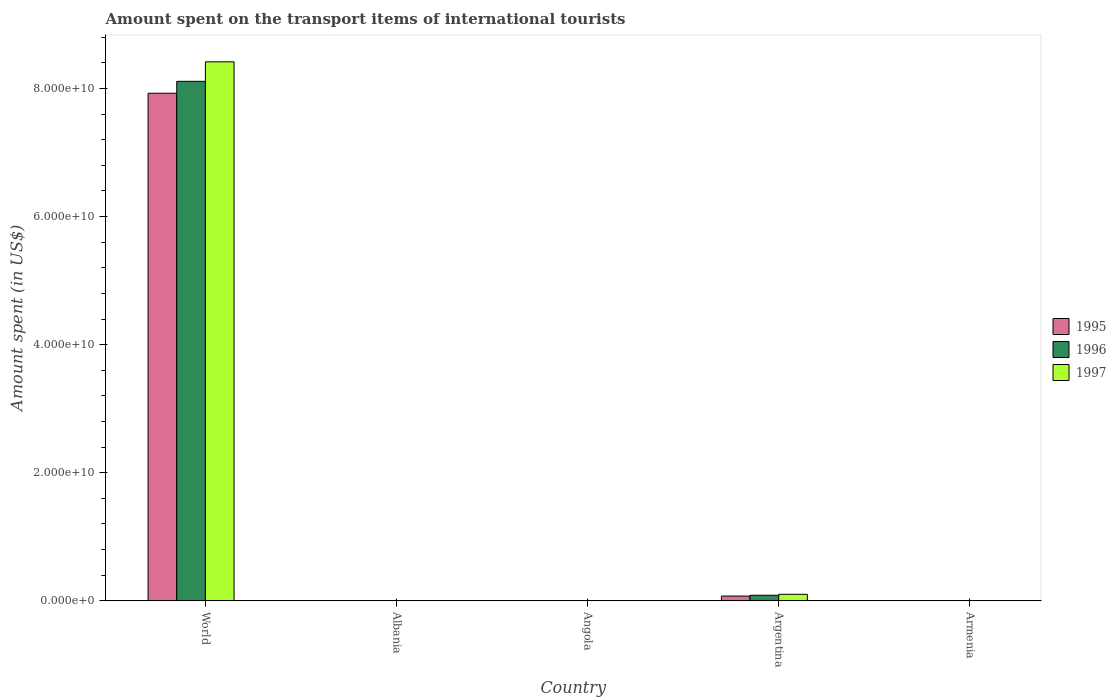How many different coloured bars are there?
Provide a short and direct response. 3. Are the number of bars on each tick of the X-axis equal?
Provide a short and direct response. Yes. How many bars are there on the 2nd tick from the right?
Your answer should be very brief. 3. What is the label of the 5th group of bars from the left?
Your response must be concise. Armenia. What is the amount spent on the transport items of international tourists in 1995 in Angola?
Your answer should be very brief. 3.78e+07. Across all countries, what is the maximum amount spent on the transport items of international tourists in 1997?
Offer a terse response. 8.42e+1. Across all countries, what is the minimum amount spent on the transport items of international tourists in 1997?
Provide a short and direct response. 4.00e+06. In which country was the amount spent on the transport items of international tourists in 1995 minimum?
Keep it short and to the point. Armenia. What is the total amount spent on the transport items of international tourists in 1995 in the graph?
Your response must be concise. 8.00e+1. What is the difference between the amount spent on the transport items of international tourists in 1995 in Armenia and that in World?
Your response must be concise. -7.92e+1. What is the difference between the amount spent on the transport items of international tourists in 1997 in Armenia and the amount spent on the transport items of international tourists in 1995 in Angola?
Provide a succinct answer. -3.38e+07. What is the average amount spent on the transport items of international tourists in 1996 per country?
Offer a terse response. 1.64e+1. What is the difference between the amount spent on the transport items of international tourists of/in 1996 and amount spent on the transport items of international tourists of/in 1997 in Argentina?
Offer a very short reply. -1.46e+08. In how many countries, is the amount spent on the transport items of international tourists in 1995 greater than 16000000000 US$?
Keep it short and to the point. 1. What is the ratio of the amount spent on the transport items of international tourists in 1996 in Angola to that in Armenia?
Make the answer very short. 9.34. Is the amount spent on the transport items of international tourists in 1996 in Albania less than that in Angola?
Provide a succinct answer. Yes. What is the difference between the highest and the second highest amount spent on the transport items of international tourists in 1995?
Ensure brevity in your answer.  6.97e+08. What is the difference between the highest and the lowest amount spent on the transport items of international tourists in 1997?
Your response must be concise. 8.42e+1. In how many countries, is the amount spent on the transport items of international tourists in 1997 greater than the average amount spent on the transport items of international tourists in 1997 taken over all countries?
Your answer should be very brief. 1. What does the 2nd bar from the left in World represents?
Your answer should be very brief. 1996. How many bars are there?
Keep it short and to the point. 15. Are all the bars in the graph horizontal?
Ensure brevity in your answer.  No. How many countries are there in the graph?
Provide a short and direct response. 5. What is the difference between two consecutive major ticks on the Y-axis?
Ensure brevity in your answer.  2.00e+1. Are the values on the major ticks of Y-axis written in scientific E-notation?
Keep it short and to the point. Yes. Does the graph contain any zero values?
Offer a very short reply. No. Where does the legend appear in the graph?
Offer a very short reply. Center right. How are the legend labels stacked?
Offer a very short reply. Vertical. What is the title of the graph?
Keep it short and to the point. Amount spent on the transport items of international tourists. Does "2008" appear as one of the legend labels in the graph?
Make the answer very short. No. What is the label or title of the X-axis?
Make the answer very short. Country. What is the label or title of the Y-axis?
Your answer should be compact. Amount spent (in US$). What is the Amount spent (in US$) of 1995 in World?
Your answer should be compact. 7.93e+1. What is the Amount spent (in US$) in 1996 in World?
Give a very brief answer. 8.11e+1. What is the Amount spent (in US$) of 1997 in World?
Make the answer very short. 8.42e+1. What is the Amount spent (in US$) of 1995 in Albania?
Provide a short and direct response. 1.20e+07. What is the Amount spent (in US$) in 1996 in Albania?
Provide a succinct answer. 1.30e+07. What is the Amount spent (in US$) in 1995 in Angola?
Make the answer very short. 3.78e+07. What is the Amount spent (in US$) in 1996 in Angola?
Give a very brief answer. 3.74e+07. What is the Amount spent (in US$) of 1997 in Angola?
Make the answer very short. 2.72e+07. What is the Amount spent (in US$) in 1995 in Argentina?
Give a very brief answer. 7.35e+08. What is the Amount spent (in US$) in 1996 in Argentina?
Your response must be concise. 8.65e+08. What is the Amount spent (in US$) in 1997 in Argentina?
Make the answer very short. 1.01e+09. What is the Amount spent (in US$) in 1995 in Armenia?
Your answer should be compact. 9.00e+06. What is the Amount spent (in US$) of 1996 in Armenia?
Make the answer very short. 4.00e+06. What is the Amount spent (in US$) in 1997 in Armenia?
Keep it short and to the point. 4.00e+06. Across all countries, what is the maximum Amount spent (in US$) of 1995?
Offer a terse response. 7.93e+1. Across all countries, what is the maximum Amount spent (in US$) in 1996?
Provide a succinct answer. 8.11e+1. Across all countries, what is the maximum Amount spent (in US$) in 1997?
Provide a succinct answer. 8.42e+1. Across all countries, what is the minimum Amount spent (in US$) in 1995?
Your response must be concise. 9.00e+06. Across all countries, what is the minimum Amount spent (in US$) of 1996?
Your answer should be very brief. 4.00e+06. What is the total Amount spent (in US$) of 1995 in the graph?
Make the answer very short. 8.00e+1. What is the total Amount spent (in US$) of 1996 in the graph?
Your response must be concise. 8.20e+1. What is the total Amount spent (in US$) of 1997 in the graph?
Give a very brief answer. 8.52e+1. What is the difference between the Amount spent (in US$) of 1995 in World and that in Albania?
Offer a very short reply. 7.92e+1. What is the difference between the Amount spent (in US$) in 1996 in World and that in Albania?
Offer a very short reply. 8.11e+1. What is the difference between the Amount spent (in US$) of 1997 in World and that in Albania?
Offer a terse response. 8.42e+1. What is the difference between the Amount spent (in US$) of 1995 in World and that in Angola?
Your answer should be very brief. 7.92e+1. What is the difference between the Amount spent (in US$) of 1996 in World and that in Angola?
Make the answer very short. 8.11e+1. What is the difference between the Amount spent (in US$) of 1997 in World and that in Angola?
Your answer should be compact. 8.41e+1. What is the difference between the Amount spent (in US$) in 1995 in World and that in Argentina?
Keep it short and to the point. 7.85e+1. What is the difference between the Amount spent (in US$) in 1996 in World and that in Argentina?
Offer a terse response. 8.03e+1. What is the difference between the Amount spent (in US$) of 1997 in World and that in Argentina?
Provide a short and direct response. 8.32e+1. What is the difference between the Amount spent (in US$) in 1995 in World and that in Armenia?
Give a very brief answer. 7.92e+1. What is the difference between the Amount spent (in US$) of 1996 in World and that in Armenia?
Give a very brief answer. 8.11e+1. What is the difference between the Amount spent (in US$) of 1997 in World and that in Armenia?
Provide a succinct answer. 8.42e+1. What is the difference between the Amount spent (in US$) of 1995 in Albania and that in Angola?
Your answer should be very brief. -2.58e+07. What is the difference between the Amount spent (in US$) in 1996 in Albania and that in Angola?
Make the answer very short. -2.44e+07. What is the difference between the Amount spent (in US$) in 1997 in Albania and that in Angola?
Provide a short and direct response. -1.92e+07. What is the difference between the Amount spent (in US$) in 1995 in Albania and that in Argentina?
Provide a short and direct response. -7.23e+08. What is the difference between the Amount spent (in US$) in 1996 in Albania and that in Argentina?
Make the answer very short. -8.52e+08. What is the difference between the Amount spent (in US$) in 1997 in Albania and that in Argentina?
Provide a succinct answer. -1.00e+09. What is the difference between the Amount spent (in US$) in 1995 in Albania and that in Armenia?
Provide a succinct answer. 3.00e+06. What is the difference between the Amount spent (in US$) in 1996 in Albania and that in Armenia?
Ensure brevity in your answer.  9.00e+06. What is the difference between the Amount spent (in US$) in 1997 in Albania and that in Armenia?
Provide a short and direct response. 4.00e+06. What is the difference between the Amount spent (in US$) in 1995 in Angola and that in Argentina?
Your answer should be compact. -6.97e+08. What is the difference between the Amount spent (in US$) in 1996 in Angola and that in Argentina?
Offer a very short reply. -8.28e+08. What is the difference between the Amount spent (in US$) in 1997 in Angola and that in Argentina?
Ensure brevity in your answer.  -9.84e+08. What is the difference between the Amount spent (in US$) in 1995 in Angola and that in Armenia?
Provide a succinct answer. 2.88e+07. What is the difference between the Amount spent (in US$) in 1996 in Angola and that in Armenia?
Offer a very short reply. 3.34e+07. What is the difference between the Amount spent (in US$) in 1997 in Angola and that in Armenia?
Make the answer very short. 2.32e+07. What is the difference between the Amount spent (in US$) of 1995 in Argentina and that in Armenia?
Provide a succinct answer. 7.26e+08. What is the difference between the Amount spent (in US$) in 1996 in Argentina and that in Armenia?
Give a very brief answer. 8.61e+08. What is the difference between the Amount spent (in US$) in 1997 in Argentina and that in Armenia?
Make the answer very short. 1.01e+09. What is the difference between the Amount spent (in US$) of 1995 in World and the Amount spent (in US$) of 1996 in Albania?
Provide a short and direct response. 7.92e+1. What is the difference between the Amount spent (in US$) of 1995 in World and the Amount spent (in US$) of 1997 in Albania?
Keep it short and to the point. 7.92e+1. What is the difference between the Amount spent (in US$) of 1996 in World and the Amount spent (in US$) of 1997 in Albania?
Make the answer very short. 8.11e+1. What is the difference between the Amount spent (in US$) in 1995 in World and the Amount spent (in US$) in 1996 in Angola?
Offer a terse response. 7.92e+1. What is the difference between the Amount spent (in US$) in 1995 in World and the Amount spent (in US$) in 1997 in Angola?
Your answer should be compact. 7.92e+1. What is the difference between the Amount spent (in US$) of 1996 in World and the Amount spent (in US$) of 1997 in Angola?
Provide a succinct answer. 8.11e+1. What is the difference between the Amount spent (in US$) in 1995 in World and the Amount spent (in US$) in 1996 in Argentina?
Make the answer very short. 7.84e+1. What is the difference between the Amount spent (in US$) in 1995 in World and the Amount spent (in US$) in 1997 in Argentina?
Offer a terse response. 7.82e+1. What is the difference between the Amount spent (in US$) of 1996 in World and the Amount spent (in US$) of 1997 in Argentina?
Give a very brief answer. 8.01e+1. What is the difference between the Amount spent (in US$) in 1995 in World and the Amount spent (in US$) in 1996 in Armenia?
Provide a short and direct response. 7.92e+1. What is the difference between the Amount spent (in US$) of 1995 in World and the Amount spent (in US$) of 1997 in Armenia?
Make the answer very short. 7.92e+1. What is the difference between the Amount spent (in US$) in 1996 in World and the Amount spent (in US$) in 1997 in Armenia?
Make the answer very short. 8.11e+1. What is the difference between the Amount spent (in US$) in 1995 in Albania and the Amount spent (in US$) in 1996 in Angola?
Give a very brief answer. -2.54e+07. What is the difference between the Amount spent (in US$) of 1995 in Albania and the Amount spent (in US$) of 1997 in Angola?
Your answer should be compact. -1.52e+07. What is the difference between the Amount spent (in US$) in 1996 in Albania and the Amount spent (in US$) in 1997 in Angola?
Ensure brevity in your answer.  -1.42e+07. What is the difference between the Amount spent (in US$) in 1995 in Albania and the Amount spent (in US$) in 1996 in Argentina?
Offer a very short reply. -8.53e+08. What is the difference between the Amount spent (in US$) of 1995 in Albania and the Amount spent (in US$) of 1997 in Argentina?
Give a very brief answer. -9.99e+08. What is the difference between the Amount spent (in US$) of 1996 in Albania and the Amount spent (in US$) of 1997 in Argentina?
Your answer should be very brief. -9.98e+08. What is the difference between the Amount spent (in US$) in 1996 in Albania and the Amount spent (in US$) in 1997 in Armenia?
Provide a succinct answer. 9.00e+06. What is the difference between the Amount spent (in US$) in 1995 in Angola and the Amount spent (in US$) in 1996 in Argentina?
Your answer should be compact. -8.27e+08. What is the difference between the Amount spent (in US$) of 1995 in Angola and the Amount spent (in US$) of 1997 in Argentina?
Offer a very short reply. -9.73e+08. What is the difference between the Amount spent (in US$) of 1996 in Angola and the Amount spent (in US$) of 1997 in Argentina?
Keep it short and to the point. -9.74e+08. What is the difference between the Amount spent (in US$) of 1995 in Angola and the Amount spent (in US$) of 1996 in Armenia?
Give a very brief answer. 3.38e+07. What is the difference between the Amount spent (in US$) of 1995 in Angola and the Amount spent (in US$) of 1997 in Armenia?
Your response must be concise. 3.38e+07. What is the difference between the Amount spent (in US$) of 1996 in Angola and the Amount spent (in US$) of 1997 in Armenia?
Ensure brevity in your answer.  3.34e+07. What is the difference between the Amount spent (in US$) of 1995 in Argentina and the Amount spent (in US$) of 1996 in Armenia?
Provide a succinct answer. 7.31e+08. What is the difference between the Amount spent (in US$) in 1995 in Argentina and the Amount spent (in US$) in 1997 in Armenia?
Offer a very short reply. 7.31e+08. What is the difference between the Amount spent (in US$) of 1996 in Argentina and the Amount spent (in US$) of 1997 in Armenia?
Your answer should be compact. 8.61e+08. What is the average Amount spent (in US$) in 1995 per country?
Provide a short and direct response. 1.60e+1. What is the average Amount spent (in US$) of 1996 per country?
Provide a succinct answer. 1.64e+1. What is the average Amount spent (in US$) of 1997 per country?
Provide a succinct answer. 1.70e+1. What is the difference between the Amount spent (in US$) in 1995 and Amount spent (in US$) in 1996 in World?
Offer a terse response. -1.87e+09. What is the difference between the Amount spent (in US$) in 1995 and Amount spent (in US$) in 1997 in World?
Offer a very short reply. -4.91e+09. What is the difference between the Amount spent (in US$) in 1996 and Amount spent (in US$) in 1997 in World?
Your answer should be compact. -3.04e+09. What is the difference between the Amount spent (in US$) of 1995 and Amount spent (in US$) of 1996 in Albania?
Offer a terse response. -1.00e+06. What is the difference between the Amount spent (in US$) of 1995 and Amount spent (in US$) of 1997 in Albania?
Offer a terse response. 4.00e+06. What is the difference between the Amount spent (in US$) in 1996 and Amount spent (in US$) in 1997 in Albania?
Keep it short and to the point. 5.00e+06. What is the difference between the Amount spent (in US$) in 1995 and Amount spent (in US$) in 1996 in Angola?
Give a very brief answer. 4.50e+05. What is the difference between the Amount spent (in US$) of 1995 and Amount spent (in US$) of 1997 in Angola?
Make the answer very short. 1.06e+07. What is the difference between the Amount spent (in US$) of 1996 and Amount spent (in US$) of 1997 in Angola?
Offer a terse response. 1.02e+07. What is the difference between the Amount spent (in US$) in 1995 and Amount spent (in US$) in 1996 in Argentina?
Your answer should be compact. -1.30e+08. What is the difference between the Amount spent (in US$) of 1995 and Amount spent (in US$) of 1997 in Argentina?
Your answer should be compact. -2.76e+08. What is the difference between the Amount spent (in US$) of 1996 and Amount spent (in US$) of 1997 in Argentina?
Offer a very short reply. -1.46e+08. What is the difference between the Amount spent (in US$) of 1995 and Amount spent (in US$) of 1996 in Armenia?
Provide a succinct answer. 5.00e+06. What is the difference between the Amount spent (in US$) of 1995 and Amount spent (in US$) of 1997 in Armenia?
Ensure brevity in your answer.  5.00e+06. What is the ratio of the Amount spent (in US$) in 1995 in World to that in Albania?
Ensure brevity in your answer.  6604.42. What is the ratio of the Amount spent (in US$) of 1996 in World to that in Albania?
Ensure brevity in your answer.  6239.88. What is the ratio of the Amount spent (in US$) in 1997 in World to that in Albania?
Your response must be concise. 1.05e+04. What is the ratio of the Amount spent (in US$) in 1995 in World to that in Angola?
Your answer should be very brief. 2095.59. What is the ratio of the Amount spent (in US$) in 1996 in World to that in Angola?
Offer a very short reply. 2170.74. What is the ratio of the Amount spent (in US$) of 1997 in World to that in Angola?
Make the answer very short. 3094.22. What is the ratio of the Amount spent (in US$) in 1995 in World to that in Argentina?
Make the answer very short. 107.83. What is the ratio of the Amount spent (in US$) of 1996 in World to that in Argentina?
Your answer should be very brief. 93.78. What is the ratio of the Amount spent (in US$) of 1997 in World to that in Argentina?
Provide a short and direct response. 83.25. What is the ratio of the Amount spent (in US$) of 1995 in World to that in Armenia?
Ensure brevity in your answer.  8805.9. What is the ratio of the Amount spent (in US$) of 1996 in World to that in Armenia?
Offer a terse response. 2.03e+04. What is the ratio of the Amount spent (in US$) of 1997 in World to that in Armenia?
Your answer should be very brief. 2.10e+04. What is the ratio of the Amount spent (in US$) in 1995 in Albania to that in Angola?
Offer a very short reply. 0.32. What is the ratio of the Amount spent (in US$) of 1996 in Albania to that in Angola?
Your answer should be very brief. 0.35. What is the ratio of the Amount spent (in US$) of 1997 in Albania to that in Angola?
Your answer should be compact. 0.29. What is the ratio of the Amount spent (in US$) of 1995 in Albania to that in Argentina?
Your answer should be very brief. 0.02. What is the ratio of the Amount spent (in US$) of 1996 in Albania to that in Argentina?
Your answer should be compact. 0.01. What is the ratio of the Amount spent (in US$) of 1997 in Albania to that in Argentina?
Your answer should be compact. 0.01. What is the ratio of the Amount spent (in US$) of 1995 in Albania to that in Armenia?
Provide a short and direct response. 1.33. What is the ratio of the Amount spent (in US$) in 1995 in Angola to that in Argentina?
Make the answer very short. 0.05. What is the ratio of the Amount spent (in US$) in 1996 in Angola to that in Argentina?
Your answer should be very brief. 0.04. What is the ratio of the Amount spent (in US$) in 1997 in Angola to that in Argentina?
Offer a very short reply. 0.03. What is the ratio of the Amount spent (in US$) of 1995 in Angola to that in Armenia?
Your answer should be very brief. 4.2. What is the ratio of the Amount spent (in US$) of 1996 in Angola to that in Armenia?
Offer a very short reply. 9.34. What is the ratio of the Amount spent (in US$) of 1997 in Angola to that in Armenia?
Ensure brevity in your answer.  6.8. What is the ratio of the Amount spent (in US$) in 1995 in Argentina to that in Armenia?
Provide a succinct answer. 81.67. What is the ratio of the Amount spent (in US$) of 1996 in Argentina to that in Armenia?
Make the answer very short. 216.25. What is the ratio of the Amount spent (in US$) in 1997 in Argentina to that in Armenia?
Ensure brevity in your answer.  252.75. What is the difference between the highest and the second highest Amount spent (in US$) of 1995?
Keep it short and to the point. 7.85e+1. What is the difference between the highest and the second highest Amount spent (in US$) of 1996?
Your answer should be very brief. 8.03e+1. What is the difference between the highest and the second highest Amount spent (in US$) of 1997?
Offer a very short reply. 8.32e+1. What is the difference between the highest and the lowest Amount spent (in US$) of 1995?
Provide a short and direct response. 7.92e+1. What is the difference between the highest and the lowest Amount spent (in US$) of 1996?
Provide a succinct answer. 8.11e+1. What is the difference between the highest and the lowest Amount spent (in US$) in 1997?
Give a very brief answer. 8.42e+1. 